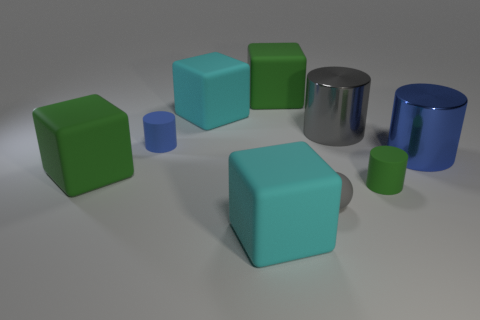Can you describe the texture and material properties of the objects? Certainly! The objects depicted in the image display a variety of textures and reflectivity. The cyan and green objects are rubber cubes and a rubber ball, exhibiting a slightly matte surface that diffuses light softly, indicative of a rubbery texture. The blue objects are made of a glossier material, likely metal, with reflective properties that provide sharp highlights and clear reflections, creating a sleek and smooth appearance. 